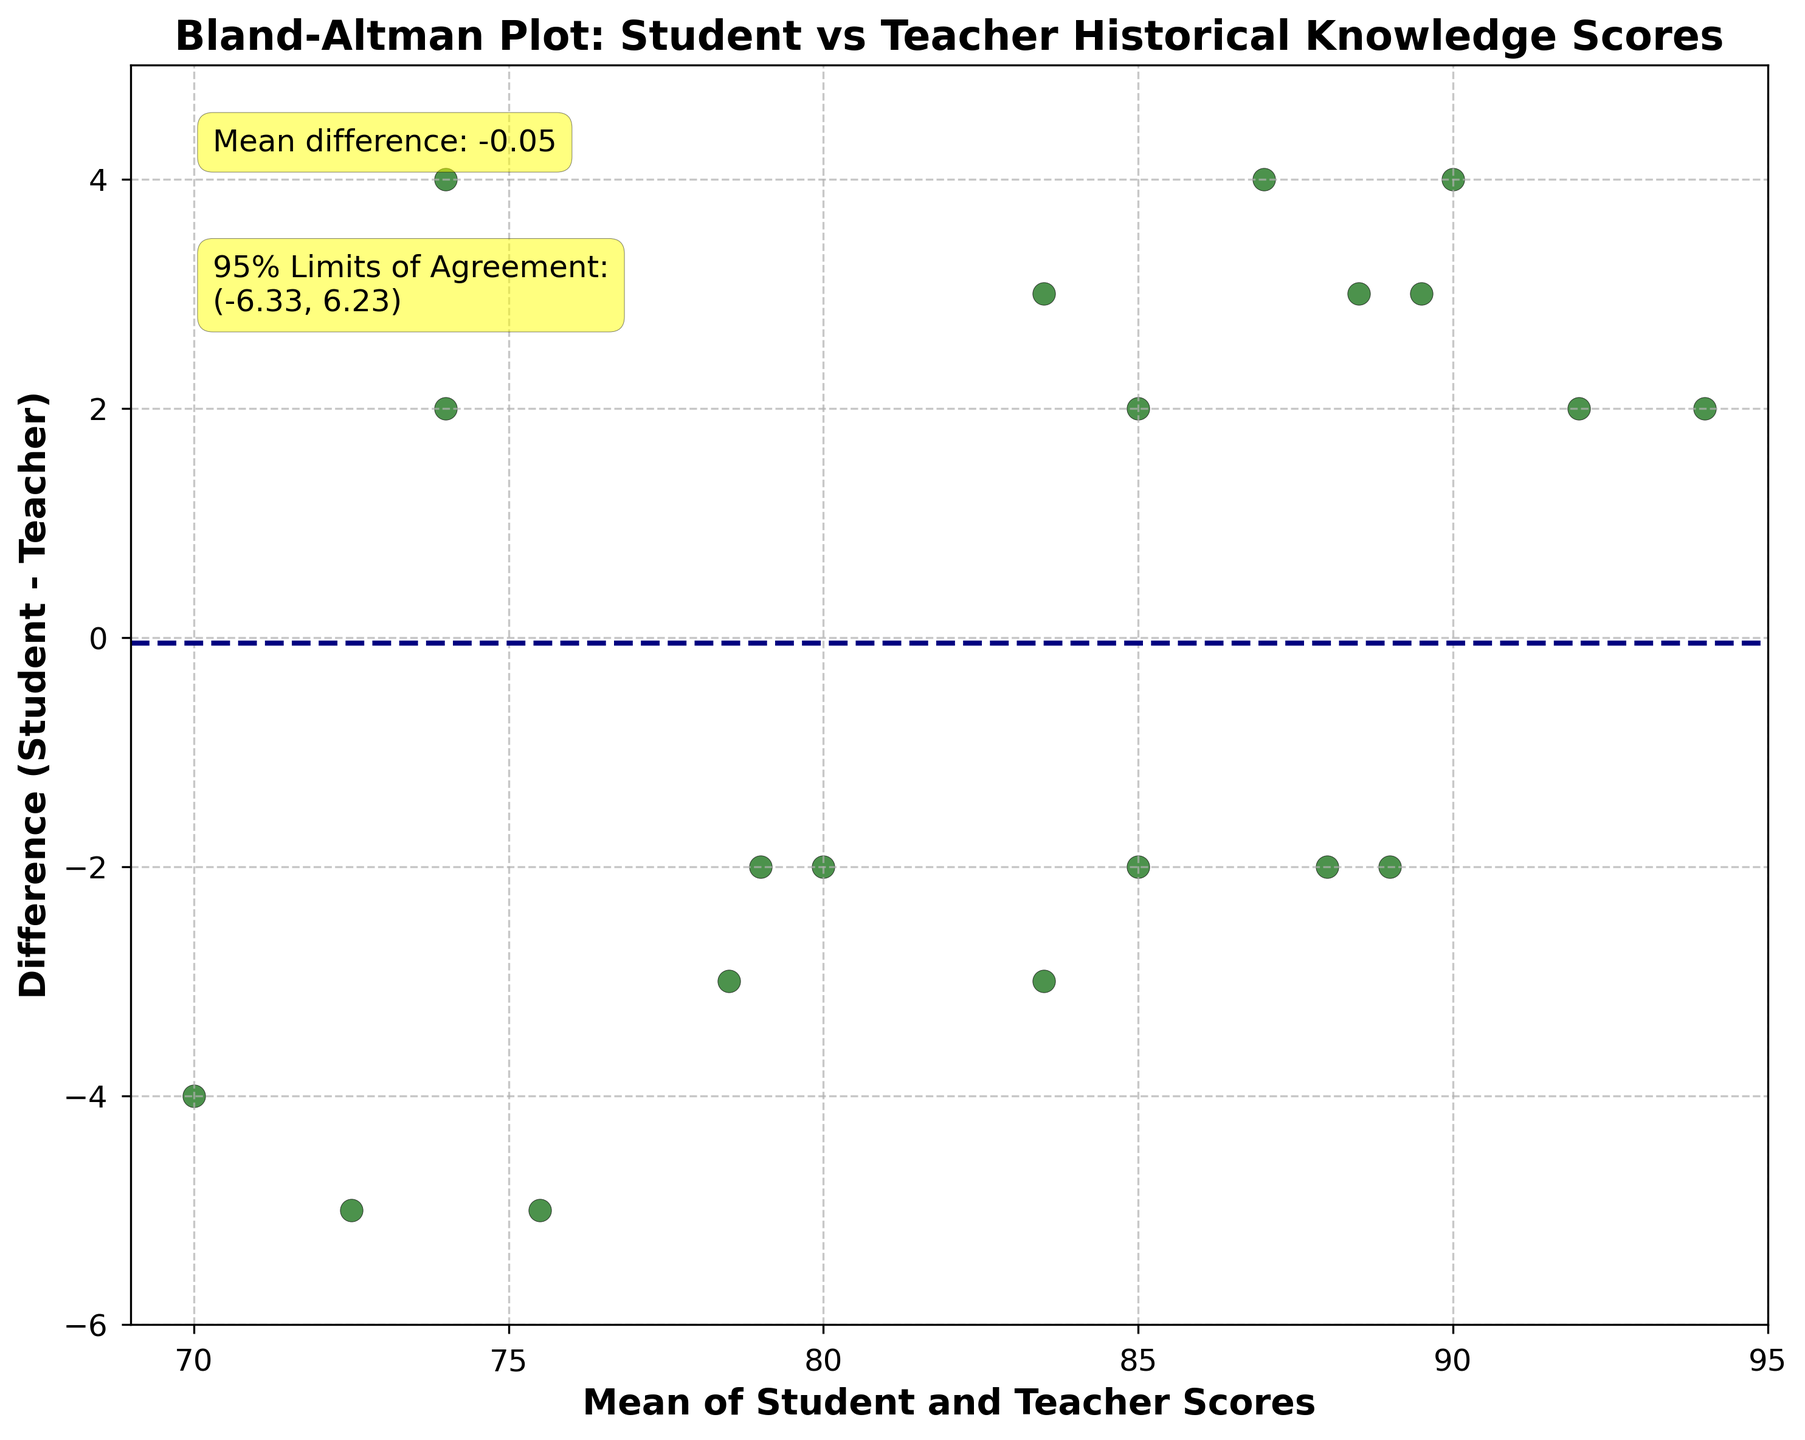What's the title of the plot? The title is displayed at the top of the plot, written in bold and should describe what the plot represents. The title given is "Bland-Altman Plot: Student vs Teacher Historical Knowledge Scores".
Answer: Bland-Altman Plot: Student vs Teacher Historical Knowledge Scores What do the x and y axes represent? The labels on the axes describe what each axis represents. The x-axis is labeled "Mean of Student and Teacher Scores," and the y-axis is labeled "Difference (Student - Teacher)".
Answer: x-axis: Mean of Student and Teacher Scores, y-axis: Difference (Student - Teacher) How many data points are displayed on the plot? Each data point is represented by a scatter point on the plot. By counting these points, we can determine the total number. There are exactly 20 points.
Answer: 20 What is the mean difference of the student and teacher scores? The mean difference is visually indicated by a horizontal dashed line and annotated in the plot as "Mean difference: X" where X is the value. Because it's annotated directly on the plot, we can read it as "Mean difference: 0.70".
Answer: 0.70 What are the 95% limits of agreement? These limits are indicated by two horizontal dotted lines and annotated on the plot. The annotation reads "95% Limits of Agreement: (-4.88, 6.28)," providing the lower and upper limits.
Answer: (-4.88, 6.28) Which data point has the largest positive difference? By observing the scatter points, the one with the largest positive difference will be farthest upwards on the y-axis. The highest point is at approximately (81, 5), and comparing with the data, it matches the (Student, Teacher) pair (70, 75) yielding a difference of 5.
Answer: (70, 75) Which mean value corresponds to a difference of 2? Finding the scatter points directly at the y-coordinate of 2, we see these points align near mean values of 81, 84, and 89-ish. From cross-referencing the data: these points correspond to mean values (95+93)/2, (86+84)/2, (75+73)/2, (93+91)/2, which are 94, 85, 74, and 92 respectively.
Answer: Approximately 94, 85, 74, and 92 Are most of the differences between student and teacher scores positive or negative? By counting how many points are above the x-axis (positive) versus below the x-axis (negative). Here, it appears that there are more points above the axis suggesting more positive differences.
Answer: Positive Which data point has the most significant negative difference? By identifying the lowest scatter point on the y-axis, we find the point near (75, -5). This maps closely to (Data: 70, Teacher: 75) producing a difference of -5.
Answer: (70, 75) Is there any evident bias in the student and teacher scoring based on this plot? Bias is indicated by the placement of the mean difference line relative to zero. The mean difference is close to zero (0.7), suggesting not much bias; however, slight student over-reporting is indicated.
Answer: Minor bias, students over-report slightly 